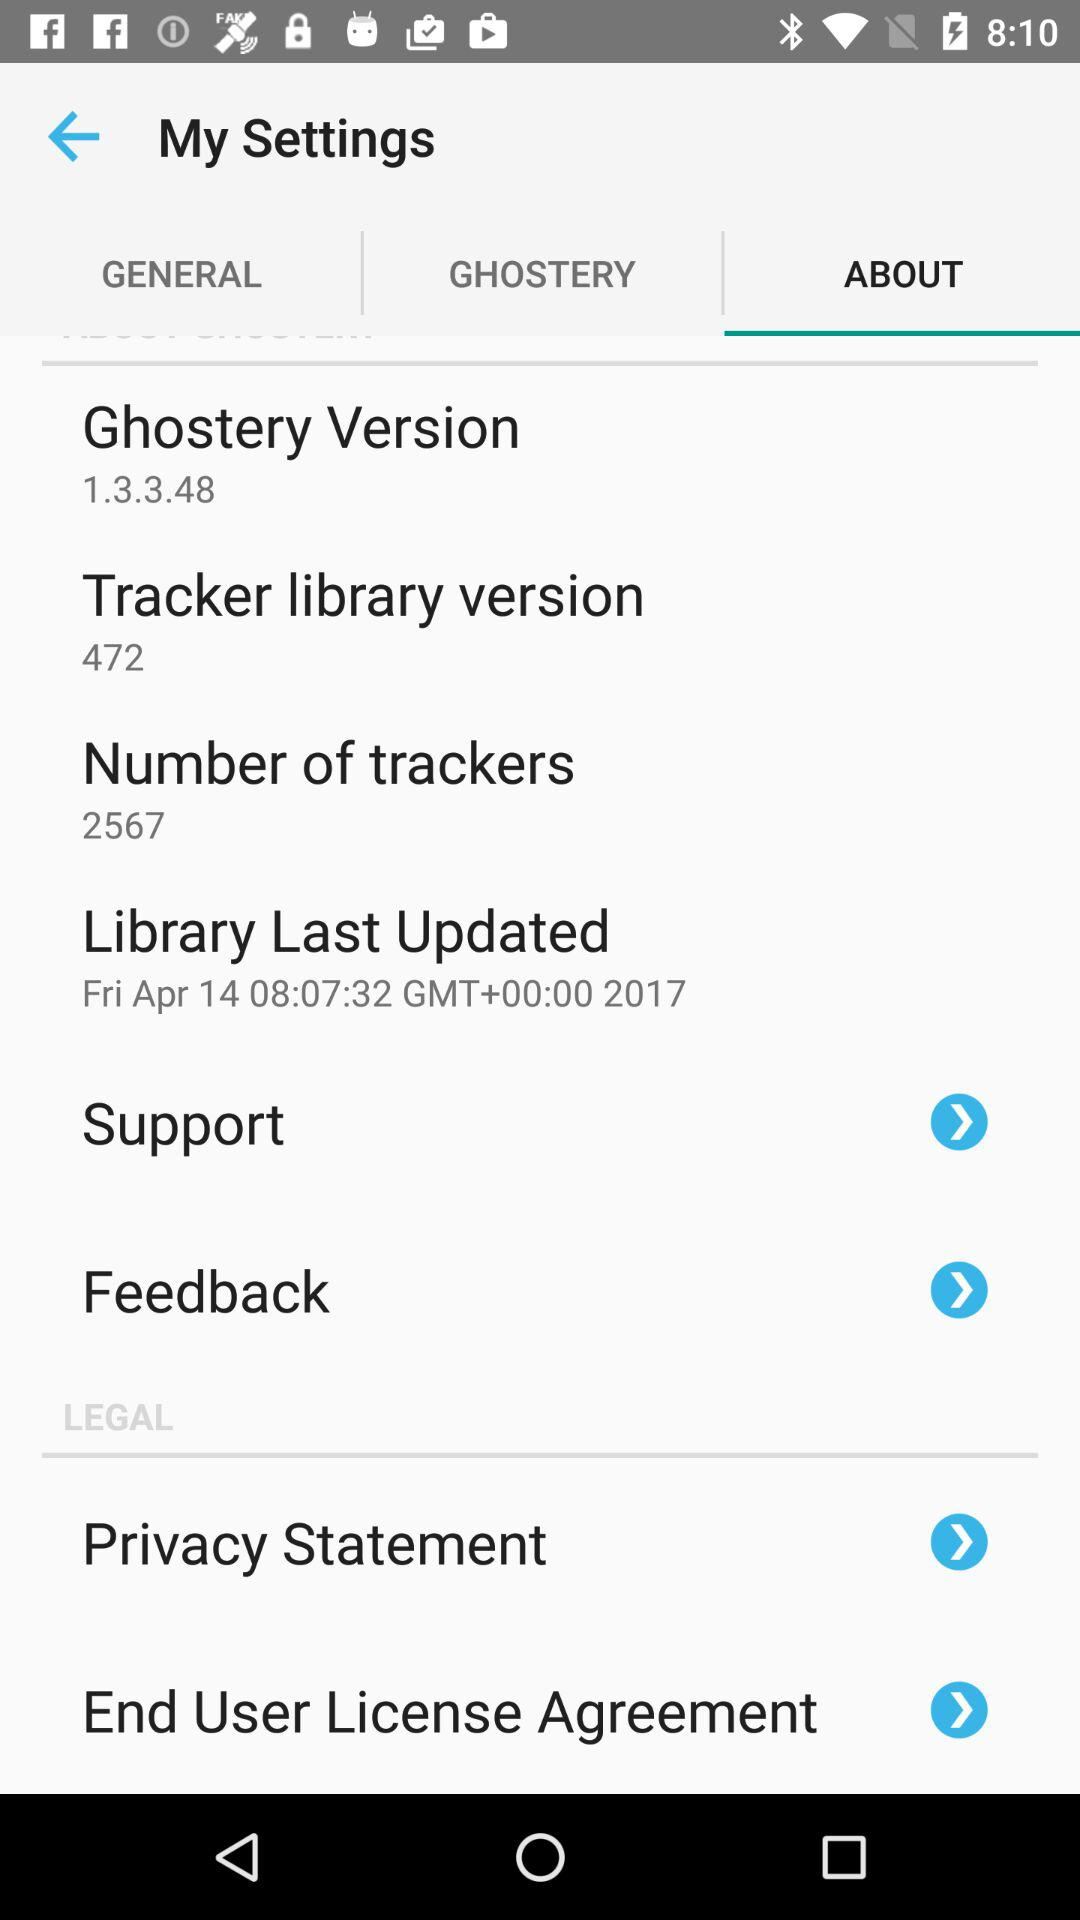Which tab is selected? The selected tab is "ABOUT". 